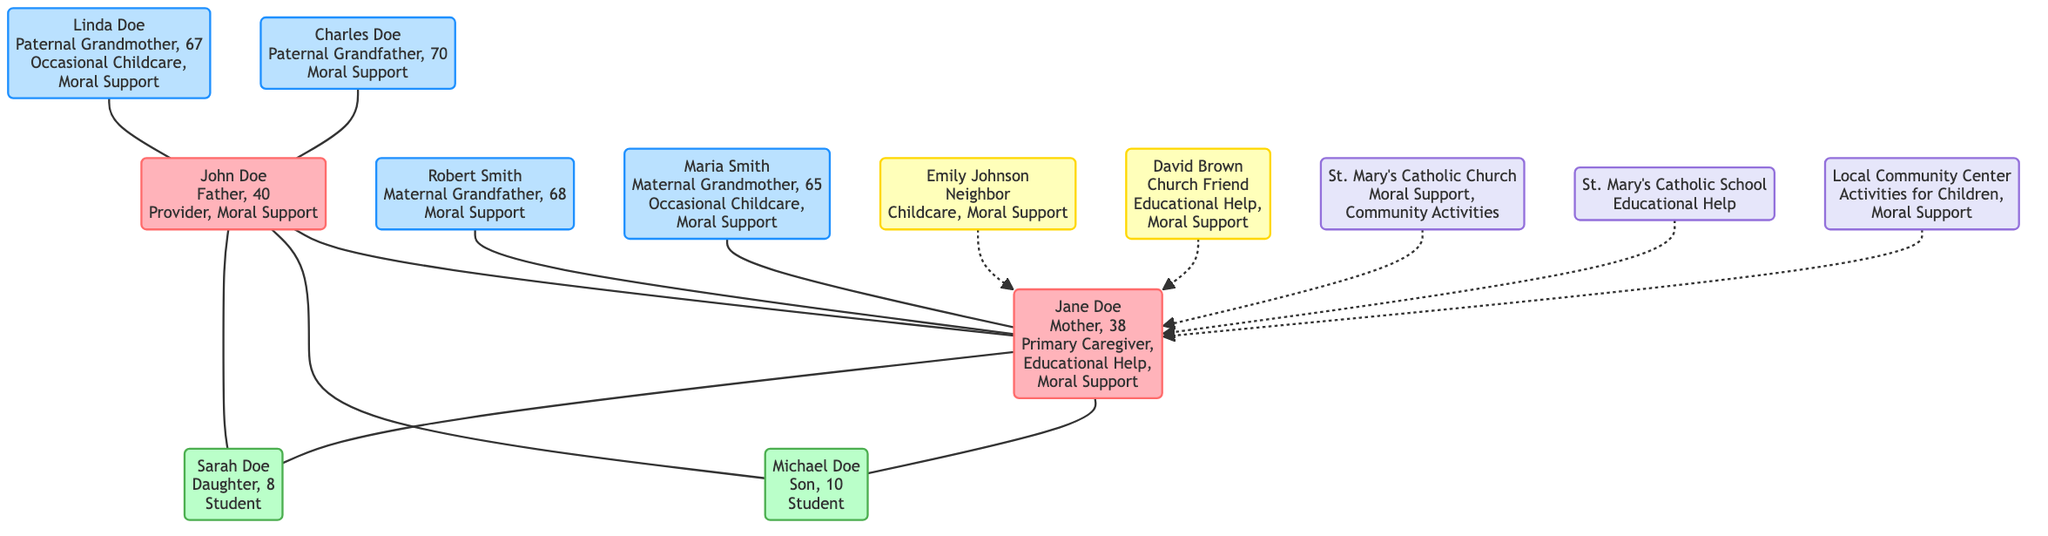What are the roles of Jane Doe? According to the diagram, Jane Doe has three roles: "Primary Caregiver," "Educational Help," and "Moral Support." These roles are listed in the information provided for her node.
Answer: Primary Caregiver, Educational Help, Moral Support How many children do John and Jane have? The diagram shows that John and Jane have two children: Michael and Sarah. This is evident as both children's names and ages are listed under the "Children" section of the family tree.
Answer: 2 What type of support does Maria Smith provide? In the family tree, Maria Smith (Maternal Grandmother) is associated with two roles: "Occasional Childcare" and "Moral Support," which are stated in her node.
Answer: Occasional Childcare, Moral Support Who provides educational help from the friends? The diagram indicates that David Brown (Church Friend) provides "Educational Help." This information can be found in his node detailing his relationship and role.
Answer: David Brown Which community role supports activities for children? The diagram lists the "Local Community Center" as having the role of "Activities for Children." This is stated in the node dedicated to the community section.
Answer: Activities for Children How is Robert Smith related to the children? Robert Smith is their maternal grandfather, as shown by the directed line from his node to Jane's node, and then to her children (Michael and Sarah). This relationship is inferred through the family tree connections.
Answer: Maternal Grandfather What is the age of Sarah Doe? Sarah Doe, according to the diagram, is indicated as being 8 years old, which is clearly listed next to her name in the children's section.
Answer: 8 Which family member provides support for both childcare and moral support? Emily Johnson, identified in the friends section of the diagram, provides both "Childcare" and "Moral Support," as listed in her node.
Answer: Emily Johnson How many moral support roles are identified in the diagram? By evaluating all nodes in the diagram, it becomes clear that moral support is identified in the roles of John Doe, Jane Doe, Robert Smith, Charles Doe, Linda Doe, Emily Johnson, David Brown, St. Mary's Catholic Church, and the Local Community Center, amounting to a total of seven specific roles.
Answer: 7 